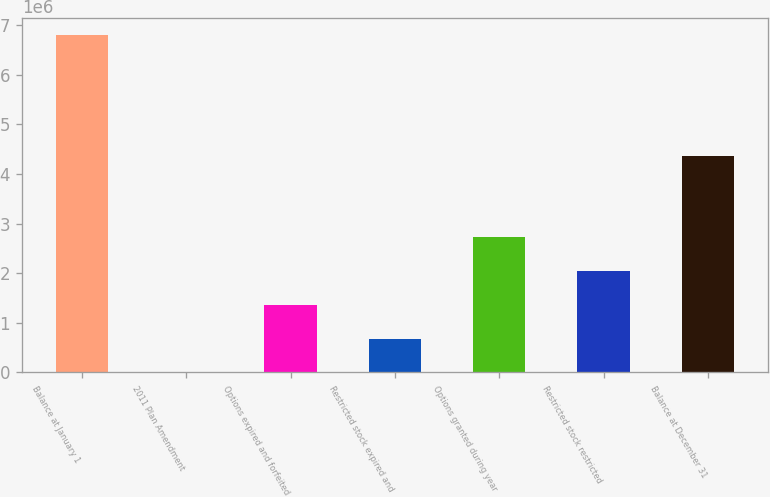Convert chart. <chart><loc_0><loc_0><loc_500><loc_500><bar_chart><fcel>Balance at January 1<fcel>2011 Plan Amendment<fcel>Options expired and forfeited<fcel>Restricted stock expired and<fcel>Options granted during year<fcel>Restricted stock restricted<fcel>Balance at December 31<nl><fcel>6.80445e+06<fcel>3.26<fcel>1.36089e+06<fcel>680448<fcel>2.72178e+06<fcel>2.04134e+06<fcel>4.36875e+06<nl></chart> 